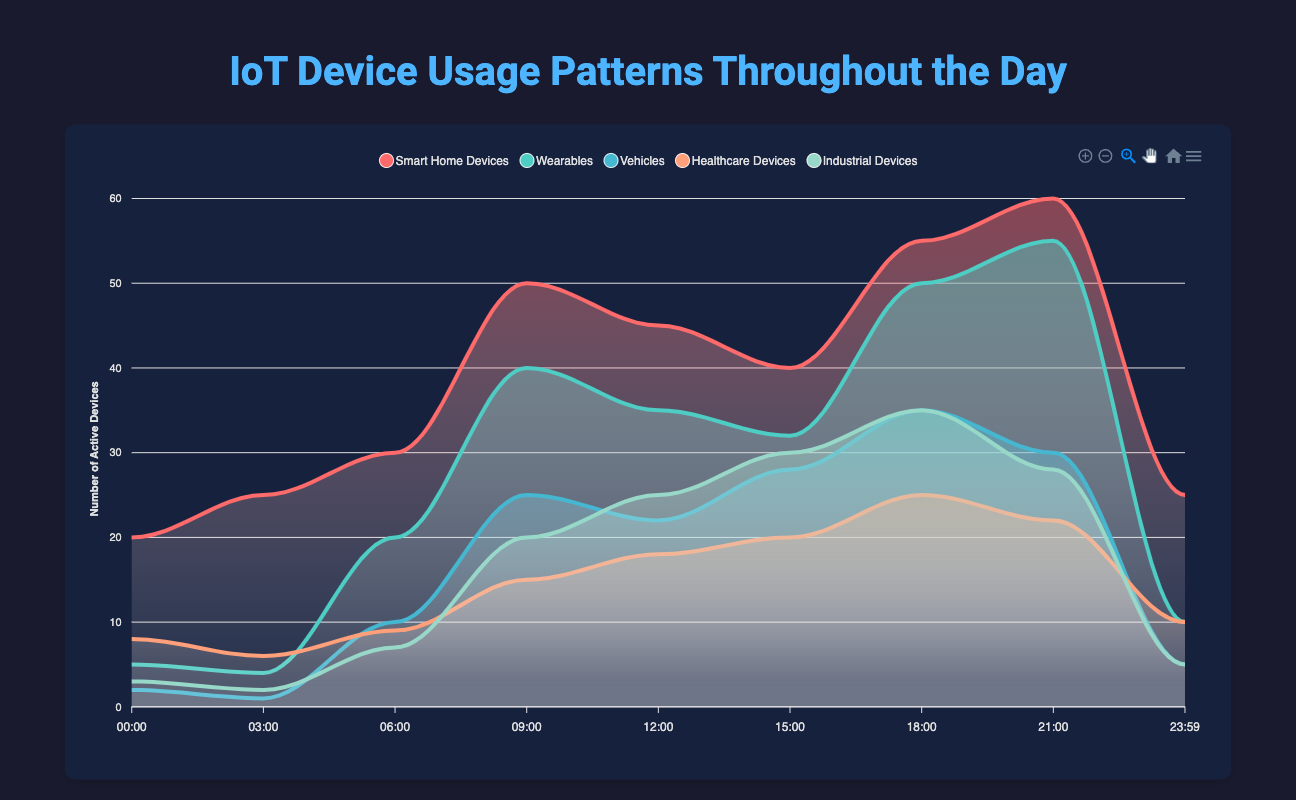What time of the day has the highest number of smart home devices in use? Looking at the time series for smart home devices, the highest point is at 21:00 with 60 devices.
Answer: 21:00 Which type of IoT device has the lowest usage at 03:00? Reviewing the data for 03:00, the vehicles have the lowest usage with only 1 active device.
Answer: Vehicles What is the total number of active healthcare devices at 12:00 and 15:00? At 12:00, there are 18 active healthcare devices, and at 15:00, there are 20. Summing these gives 18 + 20 = 38.
Answer: 38 At what time is the usage of wearables almost equal to the usage of healthcare devices? At 06:00, the wearables are at 20, and the healthcare devices are at 9. At 21:00, wearables are at 55, and healthcare devices are at 22. None of these are almost equal.
Answer: N/A Which category shows the most significant increase from 00:00 to 21:00? By calculating differences: Smart Home Devices increase from 20 to 60 (40), Wearables from 5 to 55 (50), Vehicles from 2 to 30 (28), Healthcare Devices from 8 to 22 (14), Industrial Devices from 3 to 28 (25). The wearables category shows the greatest increase (50).
Answer: Wearables Which time interval shows the largest drop in active devices for smart home devices? Checking the data between each time interval, the largest drop is from 21:00 (60 devices) to 23:59 (25 devices), which is a decrease of 35 devices.
Answer: 21:00 to 23:59 How much higher is the usage of industrial devices at 18:00 compared to 00:00? At 18:00, there are 35 industrial devices in use, compared to 3 at 00:00. The difference is 35 - 3 = 32.
Answer: 32 What is the average number of active smart home devices between 12:00 and 18:00? Smart home devices at 12:00 (45), 15:00 (40), 18:00 (55). Average = (45 + 40 + 55) / 3 = 140 / 3 ≈ 46.67.
Answer: 46.67 During which time period does the number of vehicles peak? Observing the dataset for vehicles, the peak usage of 35 occurs at 18:00.
Answer: 18:00 